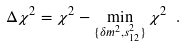<formula> <loc_0><loc_0><loc_500><loc_500>\Delta \chi ^ { 2 } = \chi ^ { 2 } - \min _ { \{ \delta m ^ { 2 } , s ^ { 2 } _ { 1 2 } \} } \chi ^ { 2 } \ .</formula> 